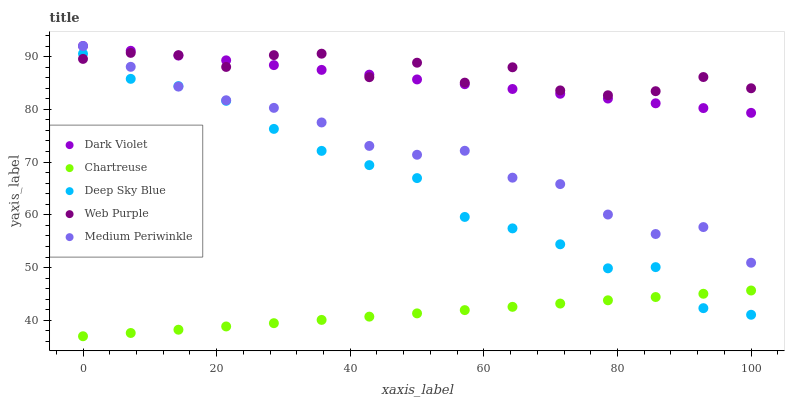Does Chartreuse have the minimum area under the curve?
Answer yes or no. Yes. Does Web Purple have the maximum area under the curve?
Answer yes or no. Yes. Does Medium Periwinkle have the minimum area under the curve?
Answer yes or no. No. Does Medium Periwinkle have the maximum area under the curve?
Answer yes or no. No. Is Dark Violet the smoothest?
Answer yes or no. Yes. Is Web Purple the roughest?
Answer yes or no. Yes. Is Chartreuse the smoothest?
Answer yes or no. No. Is Chartreuse the roughest?
Answer yes or no. No. Does Chartreuse have the lowest value?
Answer yes or no. Yes. Does Medium Periwinkle have the lowest value?
Answer yes or no. No. Does Dark Violet have the highest value?
Answer yes or no. Yes. Does Chartreuse have the highest value?
Answer yes or no. No. Is Chartreuse less than Medium Periwinkle?
Answer yes or no. Yes. Is Dark Violet greater than Deep Sky Blue?
Answer yes or no. Yes. Does Deep Sky Blue intersect Web Purple?
Answer yes or no. Yes. Is Deep Sky Blue less than Web Purple?
Answer yes or no. No. Is Deep Sky Blue greater than Web Purple?
Answer yes or no. No. Does Chartreuse intersect Medium Periwinkle?
Answer yes or no. No. 